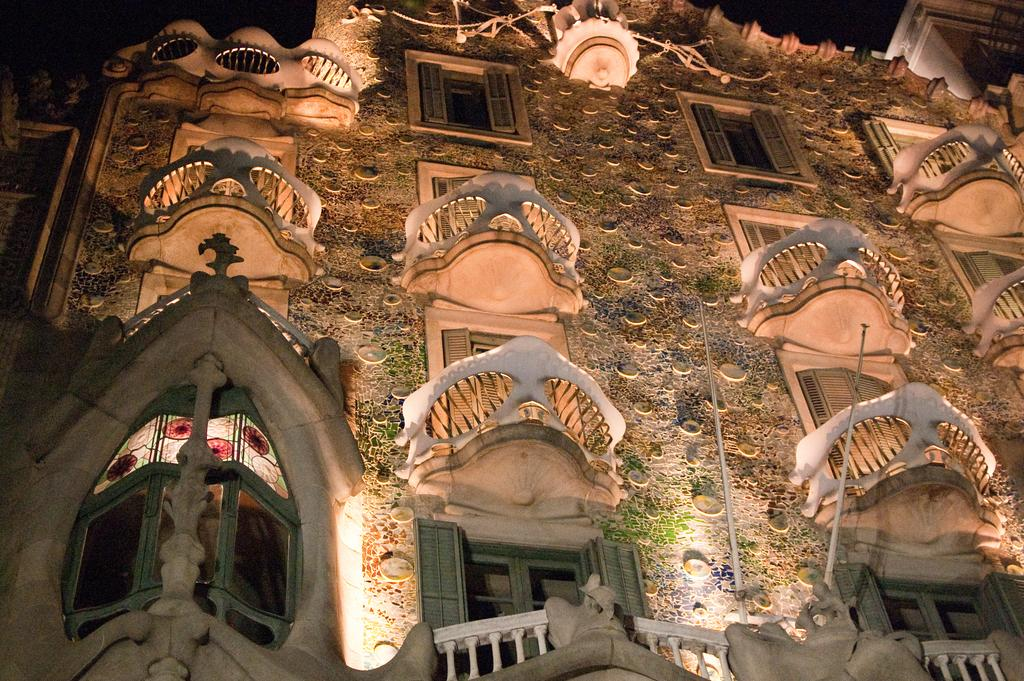What type of structure is visible in the image? There is a building in the image. What type of creature is seen cheering for the team in the image? There is no team or creature present in the image; it only features a building. 